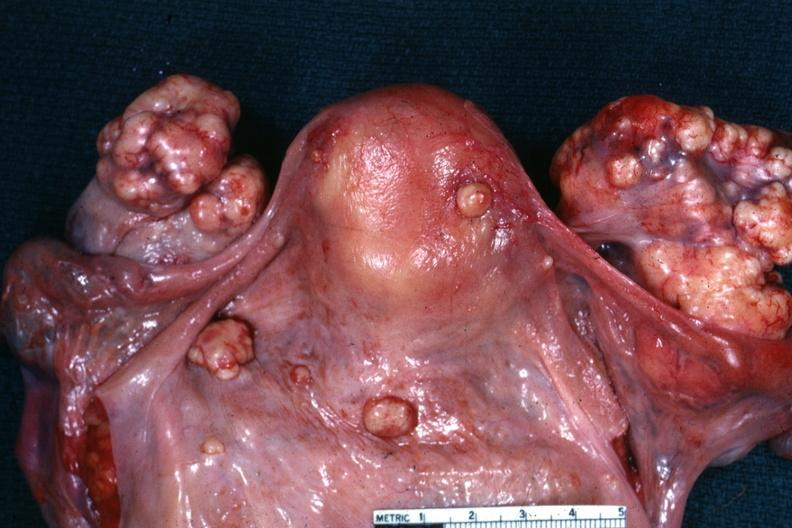what is present?
Answer the question using a single word or phrase. Krukenberg tumor 